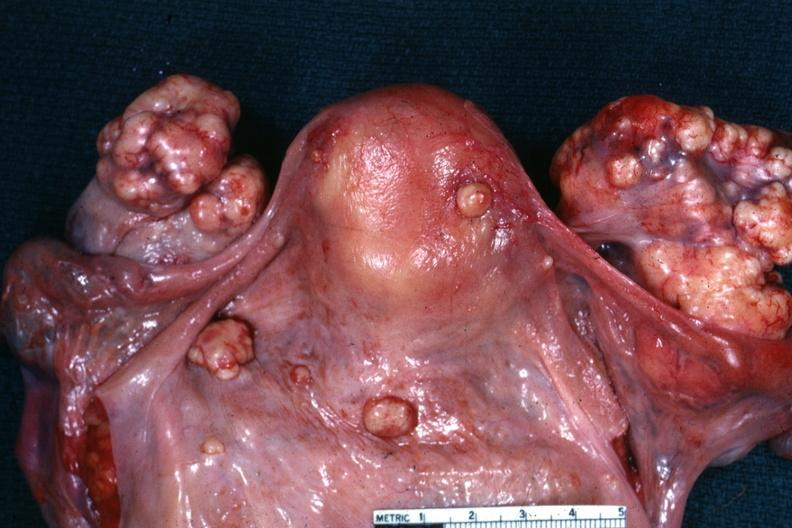what is present?
Answer the question using a single word or phrase. Krukenberg tumor 